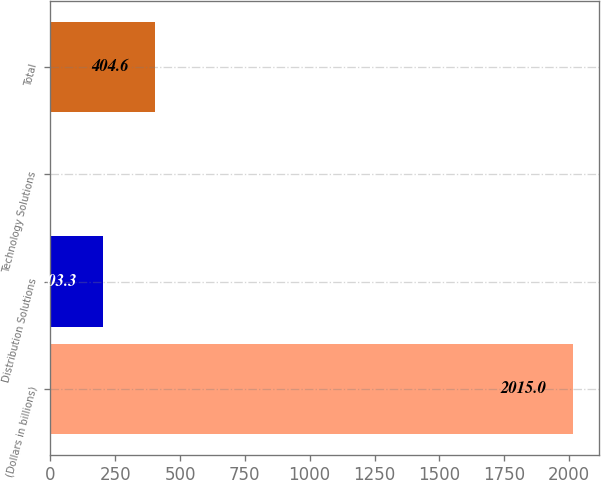<chart> <loc_0><loc_0><loc_500><loc_500><bar_chart><fcel>(Dollars in billions)<fcel>Distribution Solutions<fcel>Technology Solutions<fcel>Total<nl><fcel>2015<fcel>203.3<fcel>2<fcel>404.6<nl></chart> 